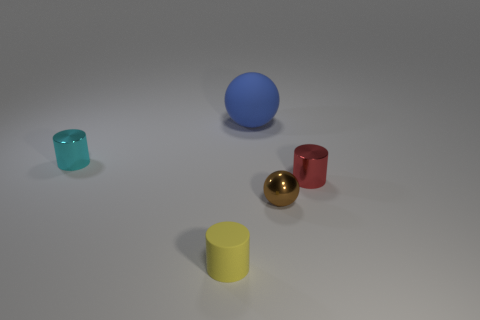Add 1 red cylinders. How many objects exist? 6 Subtract all tiny metal cylinders. How many cylinders are left? 1 Subtract all red cylinders. How many cylinders are left? 2 Subtract all spheres. How many objects are left? 3 Subtract 1 brown balls. How many objects are left? 4 Subtract all purple cylinders. Subtract all blue spheres. How many cylinders are left? 3 Subtract all metal cylinders. Subtract all balls. How many objects are left? 1 Add 5 metallic cylinders. How many metallic cylinders are left? 7 Add 2 yellow things. How many yellow things exist? 3 